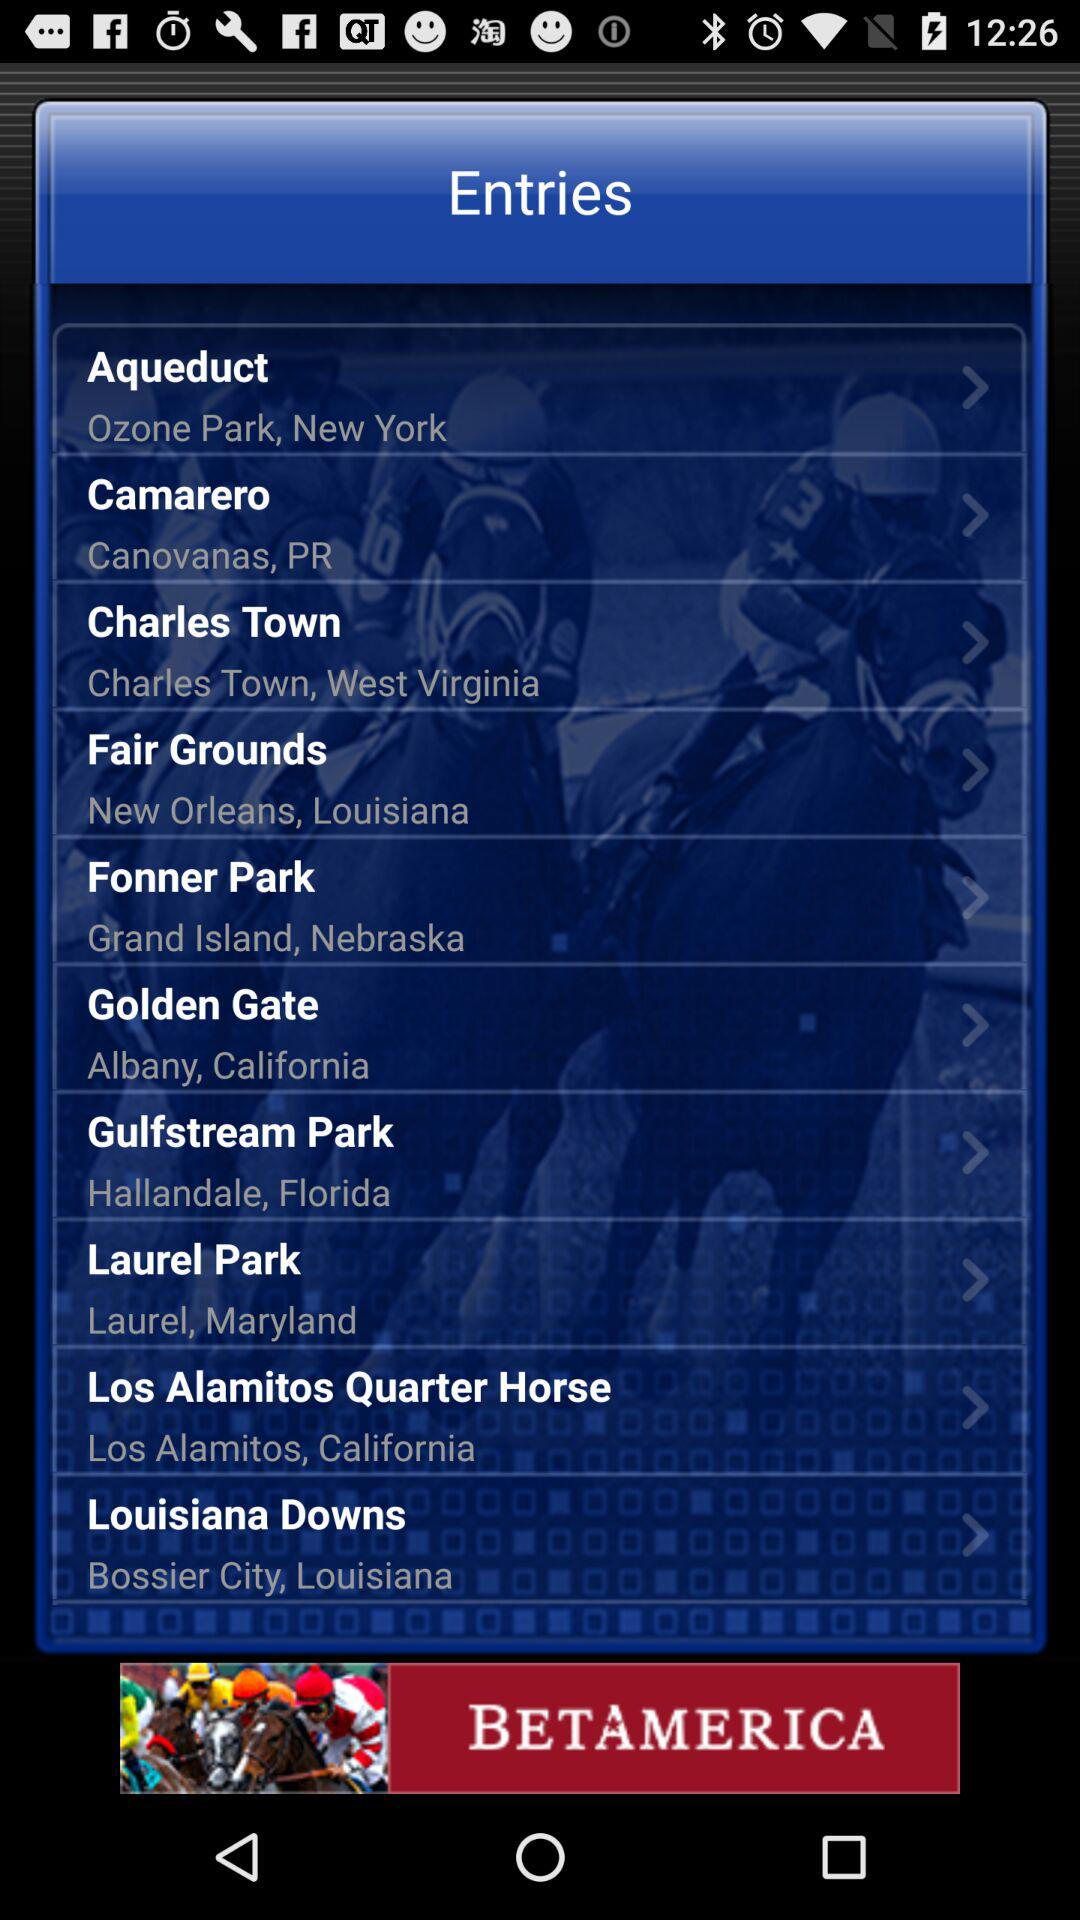What's the location of Camarero? The location of Camarero is Canovanas, PR. 